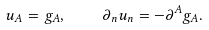<formula> <loc_0><loc_0><loc_500><loc_500>u _ { A } = g _ { A } , \quad \partial _ { n } u _ { n } = - \partial ^ { A } g _ { A } .</formula> 